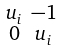<formula> <loc_0><loc_0><loc_500><loc_500>\begin{smallmatrix} u _ { i } & - 1 \\ 0 & u _ { i } \end{smallmatrix}</formula> 